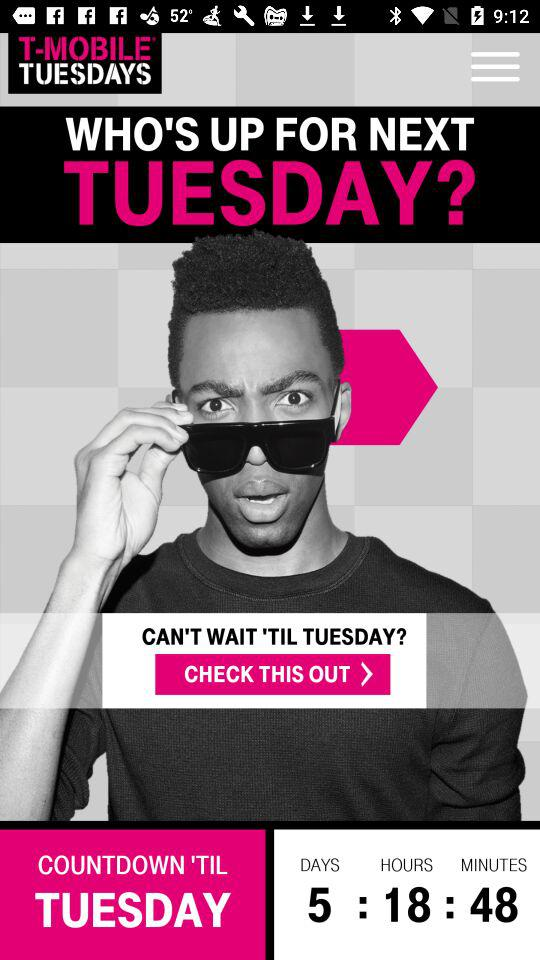How many offers are there for T-Mobile customers?
Answer the question using a single word or phrase. 4 